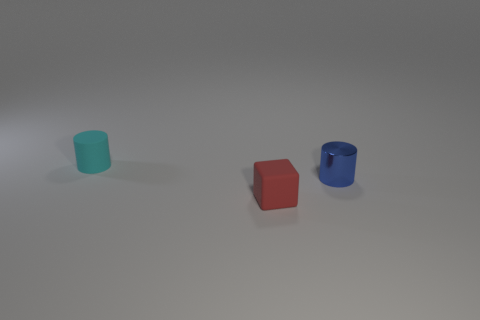Does the object in front of the blue thing have the same size as the matte thing behind the tiny blue object?
Your response must be concise. Yes. The tiny red object that is in front of the small rubber object that is behind the tiny red rubber block is what shape?
Your answer should be compact. Cube. There is a metal object; is it the same size as the cylinder that is left of the tiny red rubber block?
Provide a short and direct response. Yes. What size is the thing that is to the right of the matte object that is on the right side of the cylinder that is behind the blue object?
Ensure brevity in your answer.  Small. How many things are either small things that are on the left side of the tiny red cube or tiny gray metal objects?
Your answer should be very brief. 1. What number of small cyan cylinders are in front of the small cylinder that is to the right of the small block?
Keep it short and to the point. 0. Is the number of red matte things to the right of the matte cube greater than the number of big brown shiny cylinders?
Give a very brief answer. No. How big is the object that is both to the left of the blue cylinder and in front of the cyan cylinder?
Make the answer very short. Small. There is a tiny thing that is both behind the red rubber cube and on the left side of the blue cylinder; what shape is it?
Your answer should be very brief. Cylinder. There is a cylinder that is behind the thing to the right of the tiny cube; are there any small matte cylinders that are behind it?
Provide a succinct answer. No. 